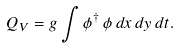Convert formula to latex. <formula><loc_0><loc_0><loc_500><loc_500>Q _ { V } = g \int \phi ^ { \dagger } \, \phi \, d x \, d y \, d t .</formula> 